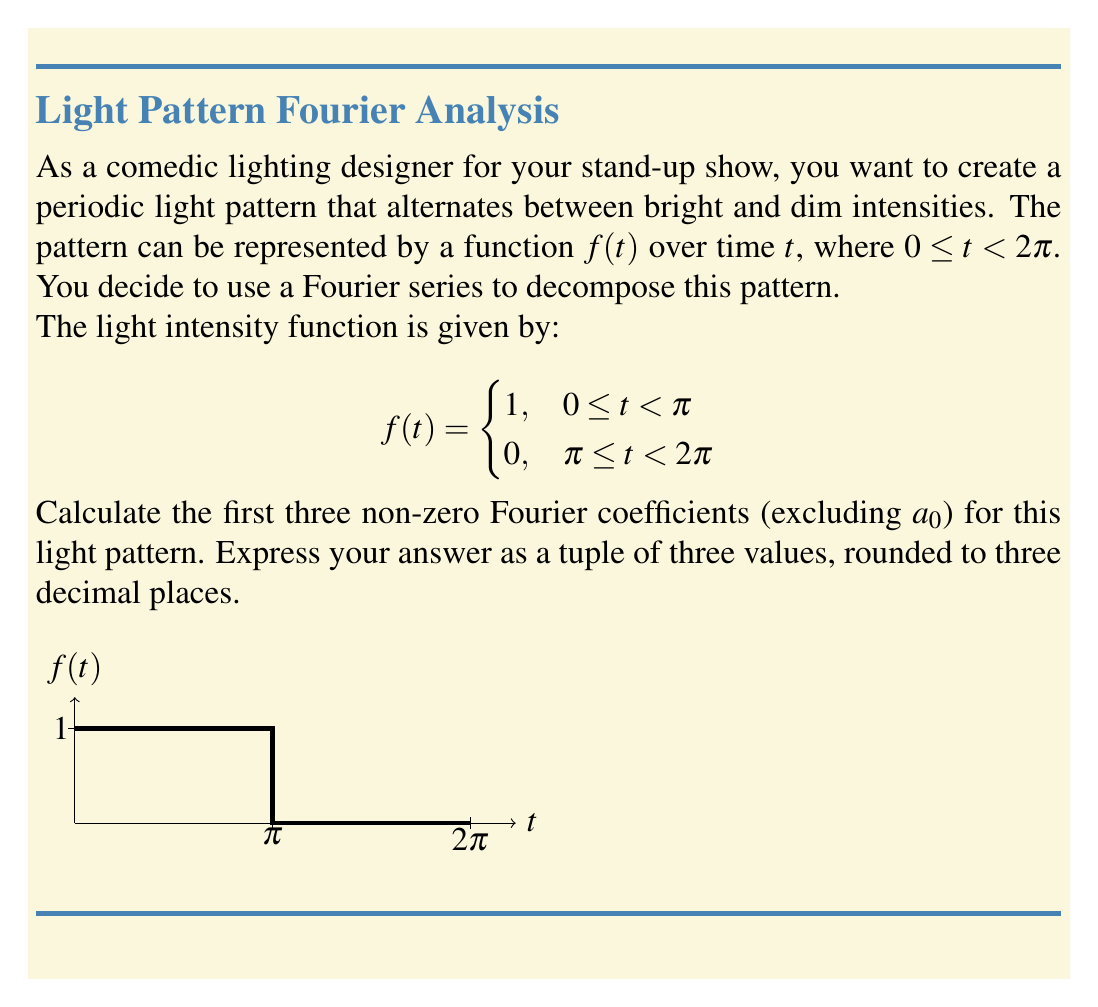Show me your answer to this math problem. Let's approach this step-by-step:

1) For a function $f(t)$ with period $2\pi$, the Fourier series is given by:

   $$f(t) = \frac{a_0}{2} + \sum_{n=1}^{\infty} (a_n \cos(nt) + b_n \sin(nt))$$

2) The Fourier coefficients are calculated using:

   $$a_n = \frac{1}{\pi} \int_0^{2\pi} f(t) \cos(nt) dt$$
   $$b_n = \frac{1}{\pi} \int_0^{2\pi} f(t) \sin(nt) dt$$

3) Let's calculate $a_n$ first:

   $$a_n = \frac{1}{\pi} \int_0^{\pi} 1 \cdot \cos(nt) dt + \frac{1}{\pi} \int_{\pi}^{2\pi} 0 \cdot \cos(nt) dt$$
   $$a_n = \frac{1}{\pi} [\frac{1}{n}\sin(nt)]_0^{\pi} = \frac{1}{n\pi}[\sin(n\pi) - \sin(0)] = 0$$

   This is zero for all $n$, so we won't use these coefficients.

4) Now, let's calculate $b_n$:

   $$b_n = \frac{1}{\pi} \int_0^{\pi} 1 \cdot \sin(nt) dt + \frac{1}{\pi} \int_{\pi}^{2\pi} 0 \cdot \sin(nt) dt$$
   $$b_n = \frac{1}{\pi} [-\frac{1}{n}\cos(nt)]_0^{\pi} = \frac{1}{n\pi}[1 - \cos(n\pi)]$$

5) For odd $n$, $\cos(n\pi) = -1$, so:
   $$b_n = \frac{2}{n\pi}$$

   For even $n$, $\cos(n\pi) = 1$, so $b_n = 0$

6) The first three non-zero coefficients are:

   $b_1 = \frac{2}{\pi} \approx 0.637$
   $b_3 = \frac{2}{3\pi} \approx 0.212$
   $b_5 = \frac{2}{5\pi} \approx 0.127$
Answer: (0.637, 0.212, 0.127) 